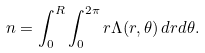Convert formula to latex. <formula><loc_0><loc_0><loc_500><loc_500>n = \int _ { 0 } ^ { R } \int _ { 0 } ^ { 2 \pi } r \Lambda ( r , \theta ) \, d r d \theta .</formula> 